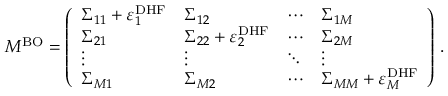Convert formula to latex. <formula><loc_0><loc_0><loc_500><loc_500>M ^ { B O } = \left ( \begin{array} { l l l l } { \Sigma _ { 1 1 } + \varepsilon _ { 1 } ^ { D H F } } & { \Sigma _ { 1 2 } } & { \cdots } & { \Sigma _ { 1 M } } \\ { \Sigma _ { 2 1 } } & { \Sigma _ { 2 2 } + \varepsilon _ { 2 } ^ { D H F } } & { \cdots } & { \Sigma _ { 2 M } } \\ { \vdots } & { \vdots } & { \ddots } & { \vdots } \\ { \Sigma _ { M 1 } } & { \Sigma _ { M 2 } } & { \cdots } & { \Sigma _ { M M } + \varepsilon _ { M } ^ { D H F } } \end{array} \right ) \, .</formula> 